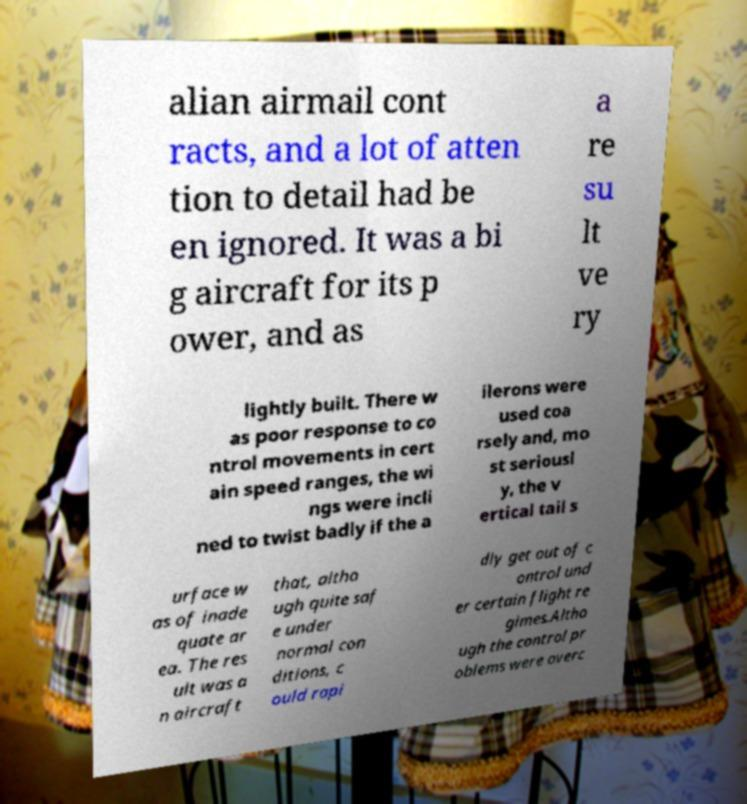Please identify and transcribe the text found in this image. alian airmail cont racts, and a lot of atten tion to detail had be en ignored. It was a bi g aircraft for its p ower, and as a re su lt ve ry lightly built. There w as poor response to co ntrol movements in cert ain speed ranges, the wi ngs were incli ned to twist badly if the a ilerons were used coa rsely and, mo st seriousl y, the v ertical tail s urface w as of inade quate ar ea. The res ult was a n aircraft that, altho ugh quite saf e under normal con ditions, c ould rapi dly get out of c ontrol und er certain flight re gimes.Altho ugh the control pr oblems were overc 